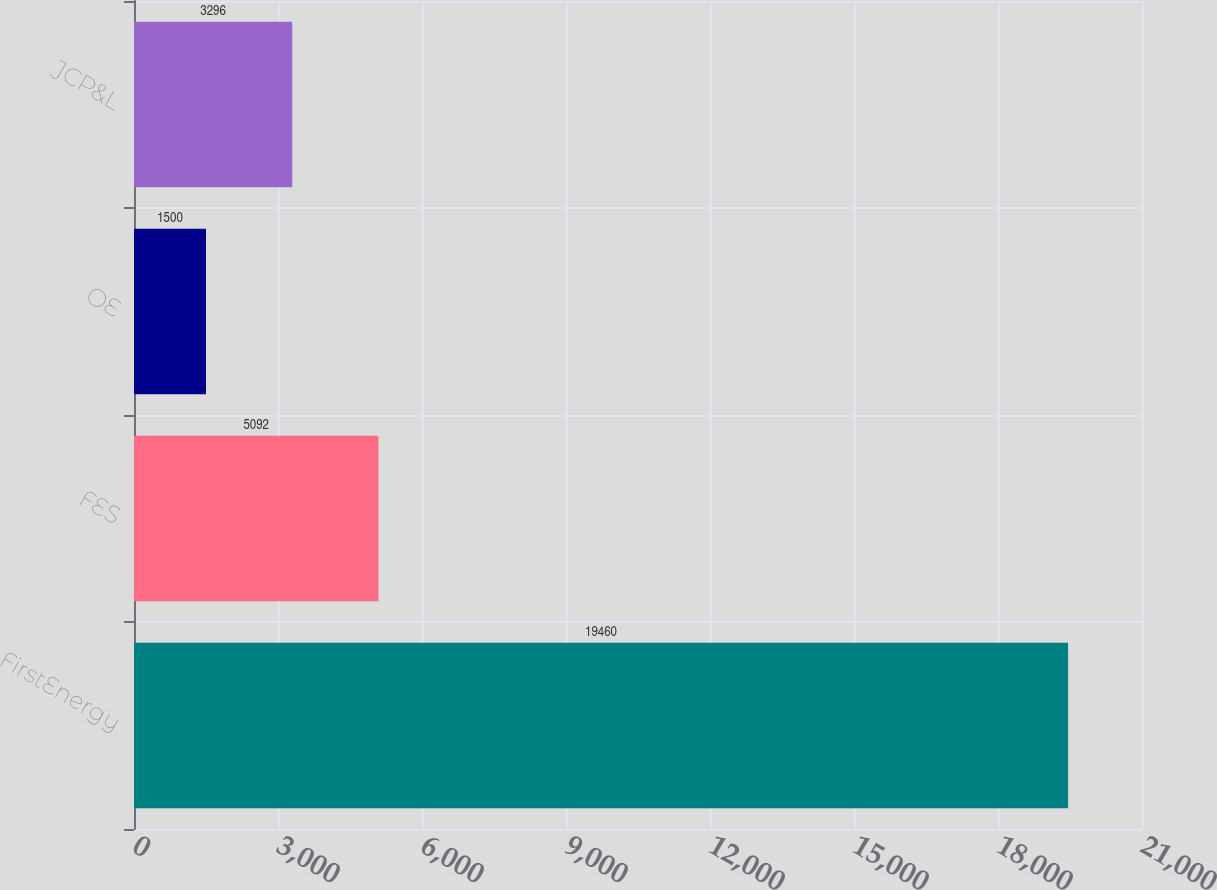Convert chart. <chart><loc_0><loc_0><loc_500><loc_500><bar_chart><fcel>FirstEnergy<fcel>FES<fcel>OE<fcel>JCP&L<nl><fcel>19460<fcel>5092<fcel>1500<fcel>3296<nl></chart> 